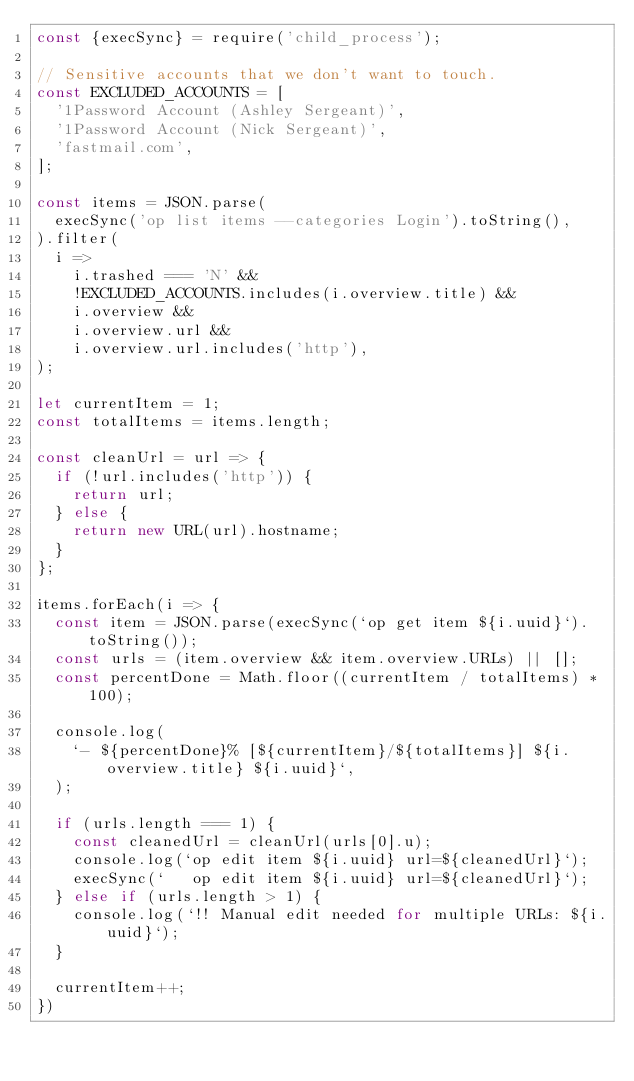<code> <loc_0><loc_0><loc_500><loc_500><_JavaScript_>const {execSync} = require('child_process');

// Sensitive accounts that we don't want to touch.
const EXCLUDED_ACCOUNTS = [
  '1Password Account (Ashley Sergeant)',
  '1Password Account (Nick Sergeant)',
  'fastmail.com',
];

const items = JSON.parse(
  execSync('op list items --categories Login').toString(),
).filter(
  i =>
    i.trashed === 'N' &&
    !EXCLUDED_ACCOUNTS.includes(i.overview.title) &&
    i.overview &&
    i.overview.url &&
    i.overview.url.includes('http'),
);

let currentItem = 1;
const totalItems = items.length;

const cleanUrl = url => {
  if (!url.includes('http')) {
    return url;
  } else {
    return new URL(url).hostname;
  }
};

items.forEach(i => {
  const item = JSON.parse(execSync(`op get item ${i.uuid}`).toString());
  const urls = (item.overview && item.overview.URLs) || [];
  const percentDone = Math.floor((currentItem / totalItems) * 100);

  console.log(
    `- ${percentDone}% [${currentItem}/${totalItems}] ${i.overview.title} ${i.uuid}`,
  );

  if (urls.length === 1) {
    const cleanedUrl = cleanUrl(urls[0].u);
    console.log(`op edit item ${i.uuid} url=${cleanedUrl}`);
    execSync(`   op edit item ${i.uuid} url=${cleanedUrl}`);
  } else if (urls.length > 1) {
    console.log(`!! Manual edit needed for multiple URLs: ${i.uuid}`);
  }

  currentItem++;
})
</code> 